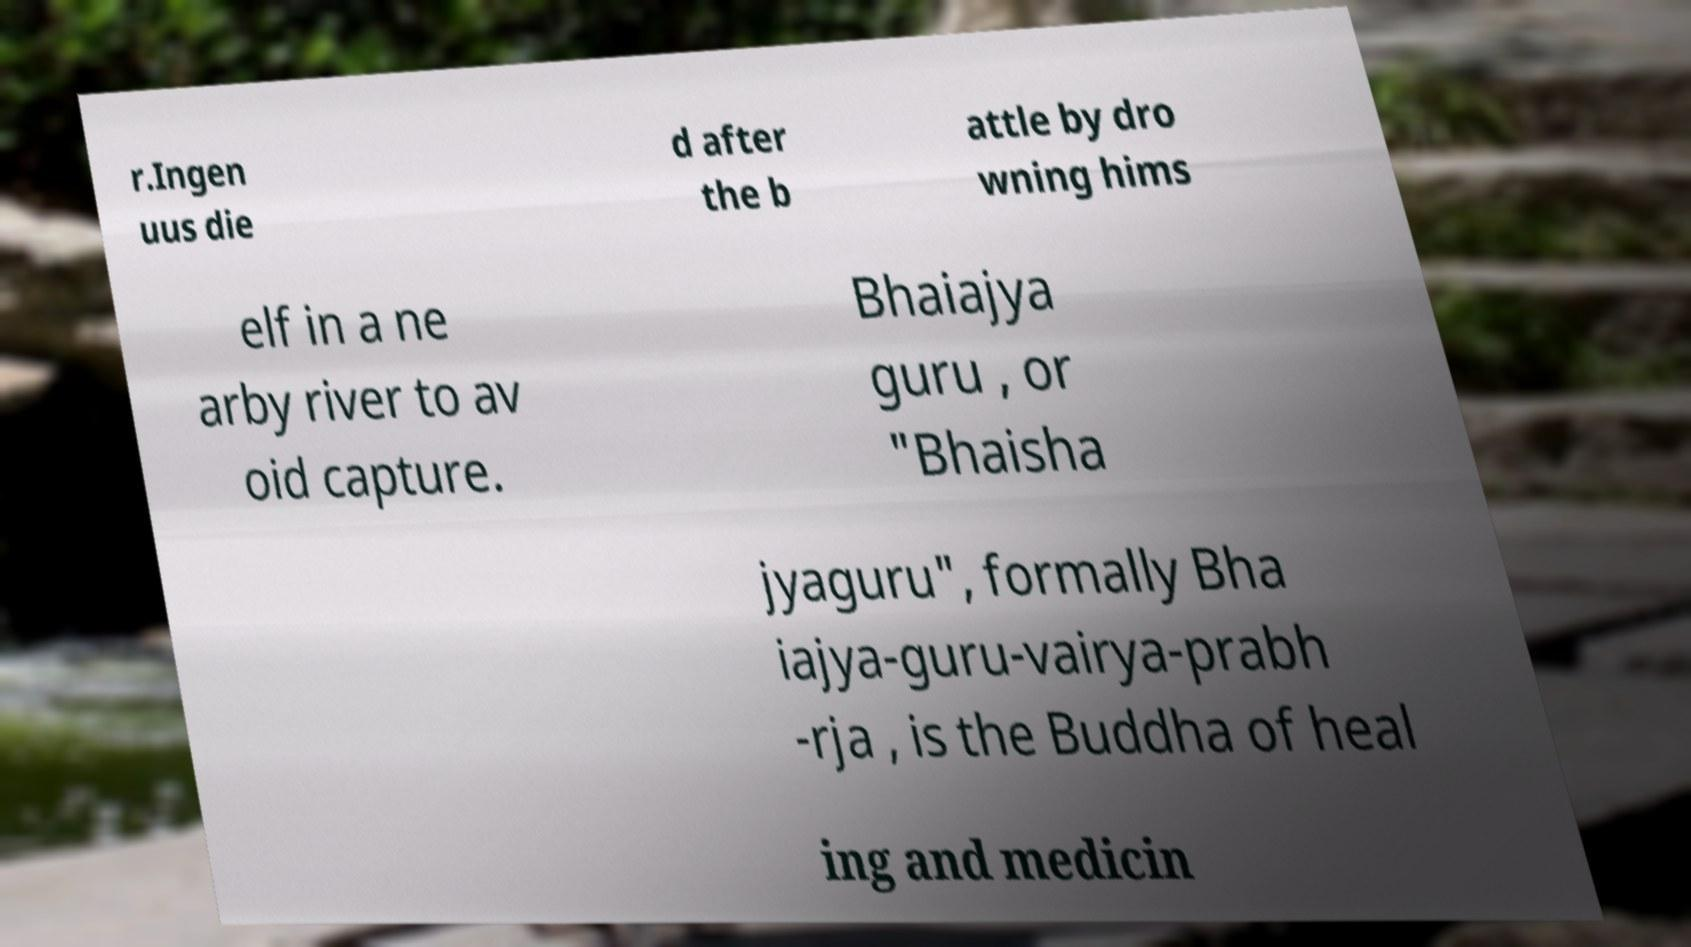Please identify and transcribe the text found in this image. r.Ingen uus die d after the b attle by dro wning hims elf in a ne arby river to av oid capture. Bhaiajya guru , or "Bhaisha jyaguru", formally Bha iajya-guru-vairya-prabh -rja , is the Buddha of heal ing and medicin 